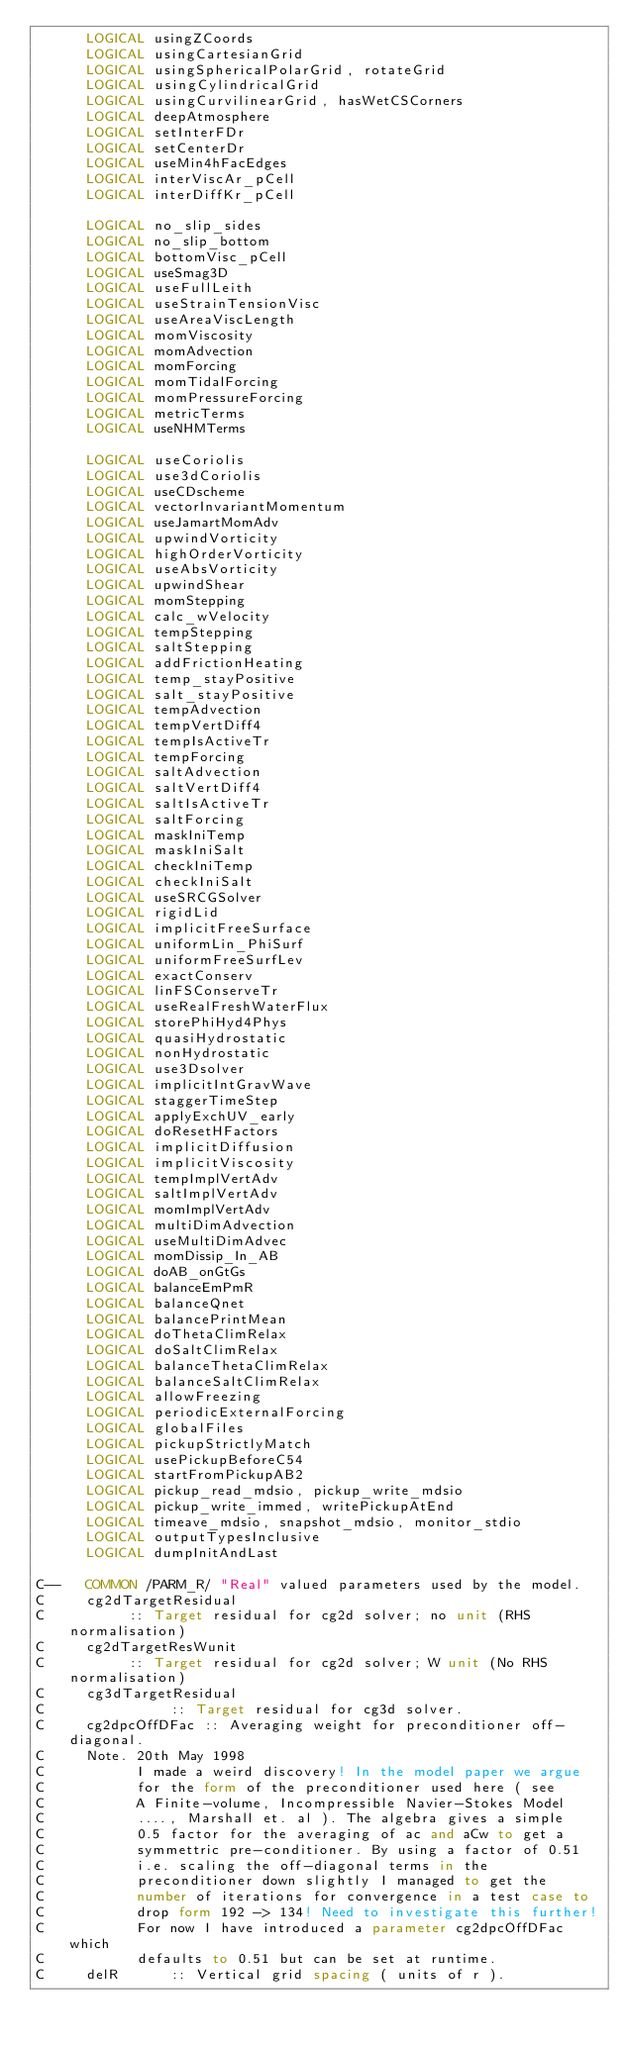<code> <loc_0><loc_0><loc_500><loc_500><_FORTRAN_>      LOGICAL usingZCoords
      LOGICAL usingCartesianGrid
      LOGICAL usingSphericalPolarGrid, rotateGrid
      LOGICAL usingCylindricalGrid
      LOGICAL usingCurvilinearGrid, hasWetCSCorners
      LOGICAL deepAtmosphere
      LOGICAL setInterFDr
      LOGICAL setCenterDr
      LOGICAL useMin4hFacEdges
      LOGICAL interViscAr_pCell
      LOGICAL interDiffKr_pCell

      LOGICAL no_slip_sides
      LOGICAL no_slip_bottom
      LOGICAL bottomVisc_pCell
      LOGICAL useSmag3D
      LOGICAL useFullLeith
      LOGICAL useStrainTensionVisc
      LOGICAL useAreaViscLength
      LOGICAL momViscosity
      LOGICAL momAdvection
      LOGICAL momForcing
      LOGICAL momTidalForcing
      LOGICAL momPressureForcing
      LOGICAL metricTerms
      LOGICAL useNHMTerms

      LOGICAL useCoriolis
      LOGICAL use3dCoriolis
      LOGICAL useCDscheme
      LOGICAL vectorInvariantMomentum
      LOGICAL useJamartMomAdv
      LOGICAL upwindVorticity
      LOGICAL highOrderVorticity
      LOGICAL useAbsVorticity
      LOGICAL upwindShear
      LOGICAL momStepping
      LOGICAL calc_wVelocity
      LOGICAL tempStepping
      LOGICAL saltStepping
      LOGICAL addFrictionHeating
      LOGICAL temp_stayPositive
      LOGICAL salt_stayPositive
      LOGICAL tempAdvection
      LOGICAL tempVertDiff4
      LOGICAL tempIsActiveTr
      LOGICAL tempForcing
      LOGICAL saltAdvection
      LOGICAL saltVertDiff4
      LOGICAL saltIsActiveTr
      LOGICAL saltForcing
      LOGICAL maskIniTemp
      LOGICAL maskIniSalt
      LOGICAL checkIniTemp
      LOGICAL checkIniSalt
      LOGICAL useSRCGSolver
      LOGICAL rigidLid
      LOGICAL implicitFreeSurface
      LOGICAL uniformLin_PhiSurf
      LOGICAL uniformFreeSurfLev
      LOGICAL exactConserv
      LOGICAL linFSConserveTr
      LOGICAL useRealFreshWaterFlux
      LOGICAL storePhiHyd4Phys
      LOGICAL quasiHydrostatic
      LOGICAL nonHydrostatic
      LOGICAL use3Dsolver
      LOGICAL implicitIntGravWave
      LOGICAL staggerTimeStep
      LOGICAL applyExchUV_early
      LOGICAL doResetHFactors
      LOGICAL implicitDiffusion
      LOGICAL implicitViscosity
      LOGICAL tempImplVertAdv
      LOGICAL saltImplVertAdv
      LOGICAL momImplVertAdv
      LOGICAL multiDimAdvection
      LOGICAL useMultiDimAdvec
      LOGICAL momDissip_In_AB
      LOGICAL doAB_onGtGs
      LOGICAL balanceEmPmR
      LOGICAL balanceQnet
      LOGICAL balancePrintMean
      LOGICAL doThetaClimRelax
      LOGICAL doSaltClimRelax
      LOGICAL balanceThetaClimRelax
      LOGICAL balanceSaltClimRelax
      LOGICAL allowFreezing
      LOGICAL periodicExternalForcing
      LOGICAL globalFiles
      LOGICAL pickupStrictlyMatch
      LOGICAL usePickupBeforeC54
      LOGICAL startFromPickupAB2
      LOGICAL pickup_read_mdsio, pickup_write_mdsio
      LOGICAL pickup_write_immed, writePickupAtEnd
      LOGICAL timeave_mdsio, snapshot_mdsio, monitor_stdio
      LOGICAL outputTypesInclusive
      LOGICAL dumpInitAndLast

C--   COMMON /PARM_R/ "Real" valued parameters used by the model.
C     cg2dTargetResidual
C          :: Target residual for cg2d solver; no unit (RHS normalisation)
C     cg2dTargetResWunit
C          :: Target residual for cg2d solver; W unit (No RHS normalisation)
C     cg3dTargetResidual
C               :: Target residual for cg3d solver.
C     cg2dpcOffDFac :: Averaging weight for preconditioner off-diagonal.
C     Note. 20th May 1998
C           I made a weird discovery! In the model paper we argue
C           for the form of the preconditioner used here ( see
C           A Finite-volume, Incompressible Navier-Stokes Model
C           ...., Marshall et. al ). The algebra gives a simple
C           0.5 factor for the averaging of ac and aCw to get a
C           symmettric pre-conditioner. By using a factor of 0.51
C           i.e. scaling the off-diagonal terms in the
C           preconditioner down slightly I managed to get the
C           number of iterations for convergence in a test case to
C           drop form 192 -> 134! Need to investigate this further!
C           For now I have introduced a parameter cg2dpcOffDFac which
C           defaults to 0.51 but can be set at runtime.
C     delR      :: Vertical grid spacing ( units of r ).</code> 